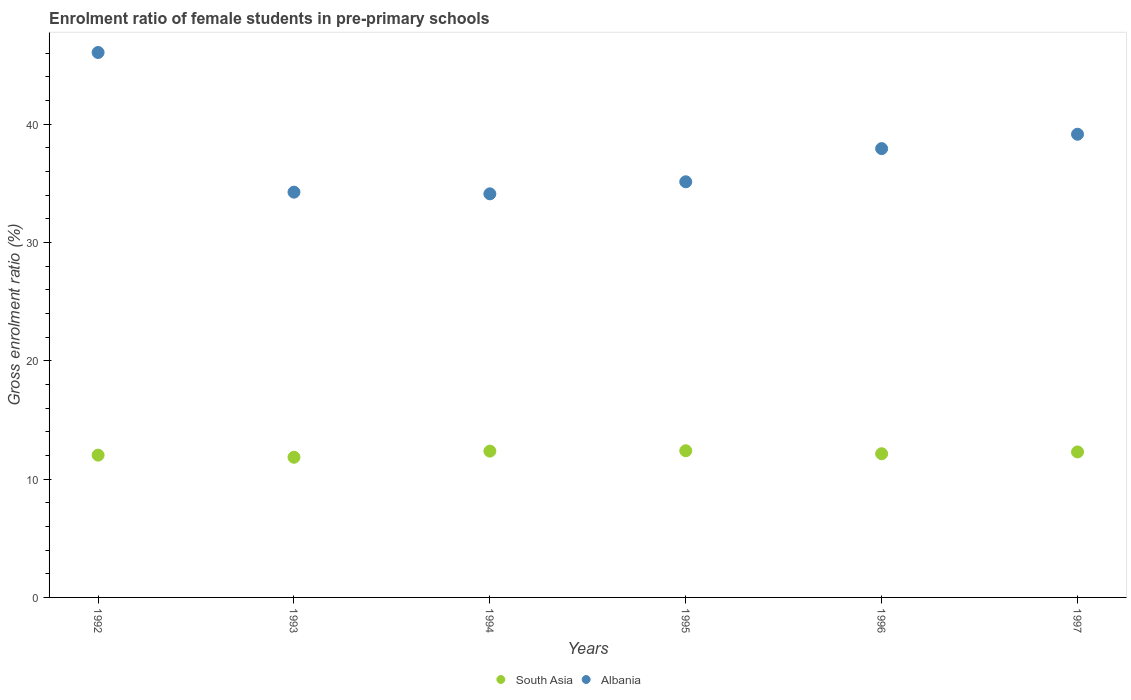How many different coloured dotlines are there?
Provide a short and direct response. 2. What is the enrolment ratio of female students in pre-primary schools in Albania in 1997?
Offer a very short reply. 39.14. Across all years, what is the maximum enrolment ratio of female students in pre-primary schools in South Asia?
Offer a terse response. 12.4. Across all years, what is the minimum enrolment ratio of female students in pre-primary schools in Albania?
Your answer should be very brief. 34.11. In which year was the enrolment ratio of female students in pre-primary schools in South Asia maximum?
Your answer should be compact. 1995. What is the total enrolment ratio of female students in pre-primary schools in South Asia in the graph?
Your response must be concise. 73.07. What is the difference between the enrolment ratio of female students in pre-primary schools in South Asia in 1993 and that in 1996?
Provide a short and direct response. -0.3. What is the difference between the enrolment ratio of female students in pre-primary schools in Albania in 1993 and the enrolment ratio of female students in pre-primary schools in South Asia in 1992?
Make the answer very short. 22.22. What is the average enrolment ratio of female students in pre-primary schools in Albania per year?
Provide a succinct answer. 37.77. In the year 1993, what is the difference between the enrolment ratio of female students in pre-primary schools in Albania and enrolment ratio of female students in pre-primary schools in South Asia?
Offer a very short reply. 22.4. What is the ratio of the enrolment ratio of female students in pre-primary schools in Albania in 1996 to that in 1997?
Make the answer very short. 0.97. Is the difference between the enrolment ratio of female students in pre-primary schools in Albania in 1992 and 1993 greater than the difference between the enrolment ratio of female students in pre-primary schools in South Asia in 1992 and 1993?
Provide a succinct answer. Yes. What is the difference between the highest and the second highest enrolment ratio of female students in pre-primary schools in South Asia?
Make the answer very short. 0.03. What is the difference between the highest and the lowest enrolment ratio of female students in pre-primary schools in Albania?
Your answer should be very brief. 11.94. In how many years, is the enrolment ratio of female students in pre-primary schools in Albania greater than the average enrolment ratio of female students in pre-primary schools in Albania taken over all years?
Your answer should be very brief. 3. Does the enrolment ratio of female students in pre-primary schools in South Asia monotonically increase over the years?
Keep it short and to the point. No. Is the enrolment ratio of female students in pre-primary schools in Albania strictly greater than the enrolment ratio of female students in pre-primary schools in South Asia over the years?
Offer a terse response. Yes. What is the difference between two consecutive major ticks on the Y-axis?
Your answer should be compact. 10. How many legend labels are there?
Offer a very short reply. 2. What is the title of the graph?
Your answer should be very brief. Enrolment ratio of female students in pre-primary schools. Does "Latin America(all income levels)" appear as one of the legend labels in the graph?
Your answer should be very brief. No. What is the Gross enrolment ratio (%) in South Asia in 1992?
Keep it short and to the point. 12.03. What is the Gross enrolment ratio (%) of Albania in 1992?
Give a very brief answer. 46.05. What is the Gross enrolment ratio (%) of South Asia in 1993?
Provide a succinct answer. 11.85. What is the Gross enrolment ratio (%) of Albania in 1993?
Your answer should be very brief. 34.25. What is the Gross enrolment ratio (%) of South Asia in 1994?
Give a very brief answer. 12.36. What is the Gross enrolment ratio (%) of Albania in 1994?
Offer a very short reply. 34.11. What is the Gross enrolment ratio (%) in South Asia in 1995?
Your answer should be very brief. 12.4. What is the Gross enrolment ratio (%) of Albania in 1995?
Ensure brevity in your answer.  35.12. What is the Gross enrolment ratio (%) of South Asia in 1996?
Provide a succinct answer. 12.14. What is the Gross enrolment ratio (%) in Albania in 1996?
Keep it short and to the point. 37.93. What is the Gross enrolment ratio (%) in South Asia in 1997?
Offer a very short reply. 12.29. What is the Gross enrolment ratio (%) of Albania in 1997?
Offer a very short reply. 39.14. Across all years, what is the maximum Gross enrolment ratio (%) in South Asia?
Give a very brief answer. 12.4. Across all years, what is the maximum Gross enrolment ratio (%) in Albania?
Provide a succinct answer. 46.05. Across all years, what is the minimum Gross enrolment ratio (%) in South Asia?
Make the answer very short. 11.85. Across all years, what is the minimum Gross enrolment ratio (%) in Albania?
Give a very brief answer. 34.11. What is the total Gross enrolment ratio (%) of South Asia in the graph?
Your answer should be compact. 73.07. What is the total Gross enrolment ratio (%) of Albania in the graph?
Keep it short and to the point. 226.6. What is the difference between the Gross enrolment ratio (%) in South Asia in 1992 and that in 1993?
Your answer should be very brief. 0.18. What is the difference between the Gross enrolment ratio (%) of Albania in 1992 and that in 1993?
Provide a succinct answer. 11.8. What is the difference between the Gross enrolment ratio (%) in South Asia in 1992 and that in 1994?
Ensure brevity in your answer.  -0.34. What is the difference between the Gross enrolment ratio (%) in Albania in 1992 and that in 1994?
Your response must be concise. 11.95. What is the difference between the Gross enrolment ratio (%) in South Asia in 1992 and that in 1995?
Your response must be concise. -0.37. What is the difference between the Gross enrolment ratio (%) in Albania in 1992 and that in 1995?
Keep it short and to the point. 10.93. What is the difference between the Gross enrolment ratio (%) of South Asia in 1992 and that in 1996?
Your answer should be very brief. -0.12. What is the difference between the Gross enrolment ratio (%) in Albania in 1992 and that in 1996?
Keep it short and to the point. 8.12. What is the difference between the Gross enrolment ratio (%) of South Asia in 1992 and that in 1997?
Offer a very short reply. -0.27. What is the difference between the Gross enrolment ratio (%) of Albania in 1992 and that in 1997?
Offer a terse response. 6.91. What is the difference between the Gross enrolment ratio (%) of South Asia in 1993 and that in 1994?
Keep it short and to the point. -0.52. What is the difference between the Gross enrolment ratio (%) of Albania in 1993 and that in 1994?
Offer a terse response. 0.14. What is the difference between the Gross enrolment ratio (%) in South Asia in 1993 and that in 1995?
Offer a very short reply. -0.55. What is the difference between the Gross enrolment ratio (%) of Albania in 1993 and that in 1995?
Offer a very short reply. -0.88. What is the difference between the Gross enrolment ratio (%) in South Asia in 1993 and that in 1996?
Give a very brief answer. -0.3. What is the difference between the Gross enrolment ratio (%) in Albania in 1993 and that in 1996?
Give a very brief answer. -3.68. What is the difference between the Gross enrolment ratio (%) in South Asia in 1993 and that in 1997?
Ensure brevity in your answer.  -0.45. What is the difference between the Gross enrolment ratio (%) in Albania in 1993 and that in 1997?
Provide a succinct answer. -4.89. What is the difference between the Gross enrolment ratio (%) in South Asia in 1994 and that in 1995?
Provide a short and direct response. -0.03. What is the difference between the Gross enrolment ratio (%) in Albania in 1994 and that in 1995?
Provide a short and direct response. -1.02. What is the difference between the Gross enrolment ratio (%) of South Asia in 1994 and that in 1996?
Give a very brief answer. 0.22. What is the difference between the Gross enrolment ratio (%) in Albania in 1994 and that in 1996?
Ensure brevity in your answer.  -3.82. What is the difference between the Gross enrolment ratio (%) in South Asia in 1994 and that in 1997?
Your response must be concise. 0.07. What is the difference between the Gross enrolment ratio (%) in Albania in 1994 and that in 1997?
Make the answer very short. -5.04. What is the difference between the Gross enrolment ratio (%) of South Asia in 1995 and that in 1996?
Provide a succinct answer. 0.25. What is the difference between the Gross enrolment ratio (%) in Albania in 1995 and that in 1996?
Ensure brevity in your answer.  -2.8. What is the difference between the Gross enrolment ratio (%) in South Asia in 1995 and that in 1997?
Your answer should be very brief. 0.1. What is the difference between the Gross enrolment ratio (%) in Albania in 1995 and that in 1997?
Provide a succinct answer. -4.02. What is the difference between the Gross enrolment ratio (%) of South Asia in 1996 and that in 1997?
Provide a short and direct response. -0.15. What is the difference between the Gross enrolment ratio (%) in Albania in 1996 and that in 1997?
Offer a terse response. -1.21. What is the difference between the Gross enrolment ratio (%) in South Asia in 1992 and the Gross enrolment ratio (%) in Albania in 1993?
Provide a short and direct response. -22.22. What is the difference between the Gross enrolment ratio (%) in South Asia in 1992 and the Gross enrolment ratio (%) in Albania in 1994?
Provide a short and direct response. -22.08. What is the difference between the Gross enrolment ratio (%) in South Asia in 1992 and the Gross enrolment ratio (%) in Albania in 1995?
Make the answer very short. -23.1. What is the difference between the Gross enrolment ratio (%) in South Asia in 1992 and the Gross enrolment ratio (%) in Albania in 1996?
Provide a succinct answer. -25.9. What is the difference between the Gross enrolment ratio (%) of South Asia in 1992 and the Gross enrolment ratio (%) of Albania in 1997?
Give a very brief answer. -27.12. What is the difference between the Gross enrolment ratio (%) in South Asia in 1993 and the Gross enrolment ratio (%) in Albania in 1994?
Keep it short and to the point. -22.26. What is the difference between the Gross enrolment ratio (%) of South Asia in 1993 and the Gross enrolment ratio (%) of Albania in 1995?
Provide a succinct answer. -23.28. What is the difference between the Gross enrolment ratio (%) in South Asia in 1993 and the Gross enrolment ratio (%) in Albania in 1996?
Your answer should be very brief. -26.08. What is the difference between the Gross enrolment ratio (%) of South Asia in 1993 and the Gross enrolment ratio (%) of Albania in 1997?
Provide a short and direct response. -27.3. What is the difference between the Gross enrolment ratio (%) in South Asia in 1994 and the Gross enrolment ratio (%) in Albania in 1995?
Offer a terse response. -22.76. What is the difference between the Gross enrolment ratio (%) in South Asia in 1994 and the Gross enrolment ratio (%) in Albania in 1996?
Make the answer very short. -25.57. What is the difference between the Gross enrolment ratio (%) in South Asia in 1994 and the Gross enrolment ratio (%) in Albania in 1997?
Make the answer very short. -26.78. What is the difference between the Gross enrolment ratio (%) of South Asia in 1995 and the Gross enrolment ratio (%) of Albania in 1996?
Give a very brief answer. -25.53. What is the difference between the Gross enrolment ratio (%) of South Asia in 1995 and the Gross enrolment ratio (%) of Albania in 1997?
Ensure brevity in your answer.  -26.75. What is the difference between the Gross enrolment ratio (%) in South Asia in 1996 and the Gross enrolment ratio (%) in Albania in 1997?
Your answer should be very brief. -27. What is the average Gross enrolment ratio (%) of South Asia per year?
Ensure brevity in your answer.  12.18. What is the average Gross enrolment ratio (%) of Albania per year?
Give a very brief answer. 37.77. In the year 1992, what is the difference between the Gross enrolment ratio (%) in South Asia and Gross enrolment ratio (%) in Albania?
Keep it short and to the point. -34.03. In the year 1993, what is the difference between the Gross enrolment ratio (%) in South Asia and Gross enrolment ratio (%) in Albania?
Your answer should be compact. -22.4. In the year 1994, what is the difference between the Gross enrolment ratio (%) of South Asia and Gross enrolment ratio (%) of Albania?
Offer a terse response. -21.74. In the year 1995, what is the difference between the Gross enrolment ratio (%) in South Asia and Gross enrolment ratio (%) in Albania?
Offer a very short reply. -22.73. In the year 1996, what is the difference between the Gross enrolment ratio (%) in South Asia and Gross enrolment ratio (%) in Albania?
Your answer should be very brief. -25.79. In the year 1997, what is the difference between the Gross enrolment ratio (%) of South Asia and Gross enrolment ratio (%) of Albania?
Offer a very short reply. -26.85. What is the ratio of the Gross enrolment ratio (%) in South Asia in 1992 to that in 1993?
Provide a short and direct response. 1.02. What is the ratio of the Gross enrolment ratio (%) in Albania in 1992 to that in 1993?
Your answer should be compact. 1.34. What is the ratio of the Gross enrolment ratio (%) of South Asia in 1992 to that in 1994?
Give a very brief answer. 0.97. What is the ratio of the Gross enrolment ratio (%) of Albania in 1992 to that in 1994?
Give a very brief answer. 1.35. What is the ratio of the Gross enrolment ratio (%) of South Asia in 1992 to that in 1995?
Ensure brevity in your answer.  0.97. What is the ratio of the Gross enrolment ratio (%) in Albania in 1992 to that in 1995?
Ensure brevity in your answer.  1.31. What is the ratio of the Gross enrolment ratio (%) in Albania in 1992 to that in 1996?
Give a very brief answer. 1.21. What is the ratio of the Gross enrolment ratio (%) in South Asia in 1992 to that in 1997?
Offer a terse response. 0.98. What is the ratio of the Gross enrolment ratio (%) in Albania in 1992 to that in 1997?
Offer a very short reply. 1.18. What is the ratio of the Gross enrolment ratio (%) of South Asia in 1993 to that in 1994?
Offer a terse response. 0.96. What is the ratio of the Gross enrolment ratio (%) of Albania in 1993 to that in 1994?
Your answer should be compact. 1. What is the ratio of the Gross enrolment ratio (%) in South Asia in 1993 to that in 1995?
Provide a succinct answer. 0.96. What is the ratio of the Gross enrolment ratio (%) of Albania in 1993 to that in 1995?
Offer a very short reply. 0.98. What is the ratio of the Gross enrolment ratio (%) in South Asia in 1993 to that in 1996?
Offer a terse response. 0.98. What is the ratio of the Gross enrolment ratio (%) of Albania in 1993 to that in 1996?
Your answer should be very brief. 0.9. What is the ratio of the Gross enrolment ratio (%) in South Asia in 1993 to that in 1997?
Provide a short and direct response. 0.96. What is the ratio of the Gross enrolment ratio (%) of Albania in 1993 to that in 1997?
Offer a very short reply. 0.88. What is the ratio of the Gross enrolment ratio (%) in Albania in 1994 to that in 1995?
Provide a short and direct response. 0.97. What is the ratio of the Gross enrolment ratio (%) of South Asia in 1994 to that in 1996?
Provide a short and direct response. 1.02. What is the ratio of the Gross enrolment ratio (%) of Albania in 1994 to that in 1996?
Offer a very short reply. 0.9. What is the ratio of the Gross enrolment ratio (%) in South Asia in 1994 to that in 1997?
Your response must be concise. 1.01. What is the ratio of the Gross enrolment ratio (%) in Albania in 1994 to that in 1997?
Your response must be concise. 0.87. What is the ratio of the Gross enrolment ratio (%) in South Asia in 1995 to that in 1996?
Provide a succinct answer. 1.02. What is the ratio of the Gross enrolment ratio (%) in Albania in 1995 to that in 1996?
Provide a short and direct response. 0.93. What is the ratio of the Gross enrolment ratio (%) in South Asia in 1995 to that in 1997?
Offer a terse response. 1.01. What is the ratio of the Gross enrolment ratio (%) of Albania in 1995 to that in 1997?
Keep it short and to the point. 0.9. What is the ratio of the Gross enrolment ratio (%) of South Asia in 1996 to that in 1997?
Give a very brief answer. 0.99. What is the difference between the highest and the second highest Gross enrolment ratio (%) in South Asia?
Provide a succinct answer. 0.03. What is the difference between the highest and the second highest Gross enrolment ratio (%) of Albania?
Offer a terse response. 6.91. What is the difference between the highest and the lowest Gross enrolment ratio (%) of South Asia?
Ensure brevity in your answer.  0.55. What is the difference between the highest and the lowest Gross enrolment ratio (%) in Albania?
Your answer should be very brief. 11.95. 